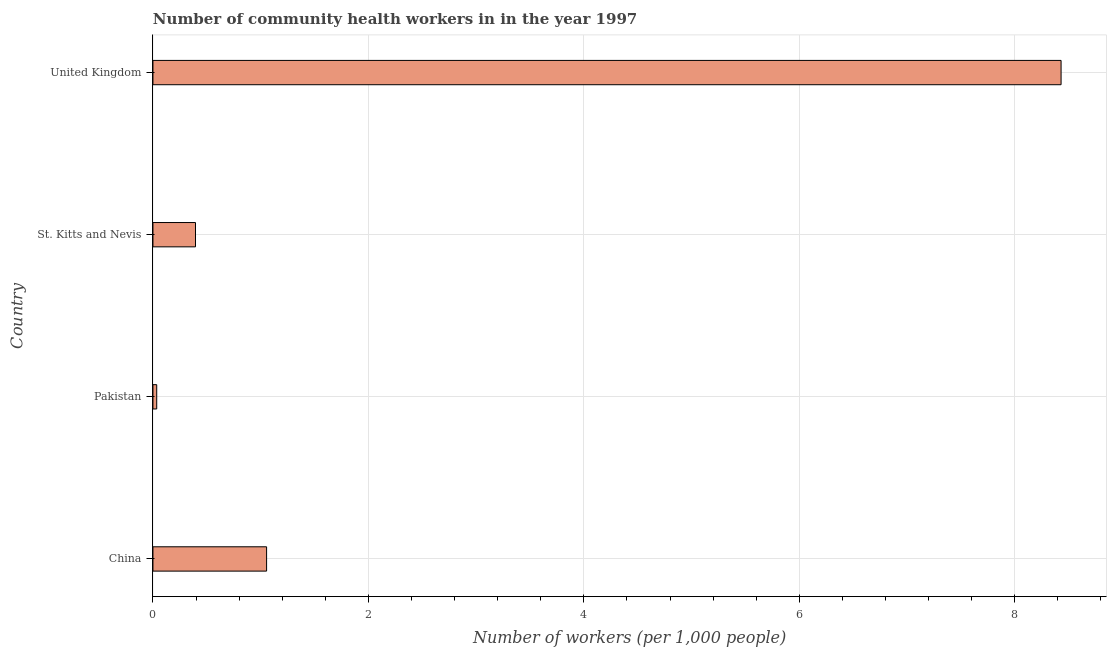What is the title of the graph?
Your response must be concise. Number of community health workers in in the year 1997. What is the label or title of the X-axis?
Offer a very short reply. Number of workers (per 1,0 people). What is the number of community health workers in United Kingdom?
Provide a succinct answer. 8.43. Across all countries, what is the maximum number of community health workers?
Give a very brief answer. 8.43. Across all countries, what is the minimum number of community health workers?
Offer a very short reply. 0.04. In which country was the number of community health workers maximum?
Provide a short and direct response. United Kingdom. In which country was the number of community health workers minimum?
Make the answer very short. Pakistan. What is the sum of the number of community health workers?
Provide a succinct answer. 9.91. What is the difference between the number of community health workers in St. Kitts and Nevis and United Kingdom?
Provide a short and direct response. -8.04. What is the average number of community health workers per country?
Your response must be concise. 2.48. What is the median number of community health workers?
Offer a terse response. 0.72. What is the ratio of the number of community health workers in China to that in Pakistan?
Offer a terse response. 30.14. Is the difference between the number of community health workers in St. Kitts and Nevis and United Kingdom greater than the difference between any two countries?
Your response must be concise. No. What is the difference between the highest and the second highest number of community health workers?
Ensure brevity in your answer.  7.38. What is the difference between the highest and the lowest number of community health workers?
Make the answer very short. 8.39. How many bars are there?
Offer a very short reply. 4. How many countries are there in the graph?
Offer a very short reply. 4. What is the difference between two consecutive major ticks on the X-axis?
Offer a terse response. 2. Are the values on the major ticks of X-axis written in scientific E-notation?
Your response must be concise. No. What is the Number of workers (per 1,000 people) of China?
Make the answer very short. 1.05. What is the Number of workers (per 1,000 people) in Pakistan?
Provide a succinct answer. 0.04. What is the Number of workers (per 1,000 people) in St. Kitts and Nevis?
Provide a succinct answer. 0.4. What is the Number of workers (per 1,000 people) in United Kingdom?
Provide a short and direct response. 8.43. What is the difference between the Number of workers (per 1,000 people) in China and St. Kitts and Nevis?
Offer a terse response. 0.66. What is the difference between the Number of workers (per 1,000 people) in China and United Kingdom?
Your answer should be very brief. -7.38. What is the difference between the Number of workers (per 1,000 people) in Pakistan and St. Kitts and Nevis?
Offer a very short reply. -0.36. What is the difference between the Number of workers (per 1,000 people) in Pakistan and United Kingdom?
Ensure brevity in your answer.  -8.39. What is the difference between the Number of workers (per 1,000 people) in St. Kitts and Nevis and United Kingdom?
Make the answer very short. -8.04. What is the ratio of the Number of workers (per 1,000 people) in China to that in Pakistan?
Offer a very short reply. 30.14. What is the ratio of the Number of workers (per 1,000 people) in China to that in St. Kitts and Nevis?
Ensure brevity in your answer.  2.67. What is the ratio of the Number of workers (per 1,000 people) in Pakistan to that in St. Kitts and Nevis?
Your answer should be very brief. 0.09. What is the ratio of the Number of workers (per 1,000 people) in Pakistan to that in United Kingdom?
Your response must be concise. 0. What is the ratio of the Number of workers (per 1,000 people) in St. Kitts and Nevis to that in United Kingdom?
Offer a terse response. 0.05. 